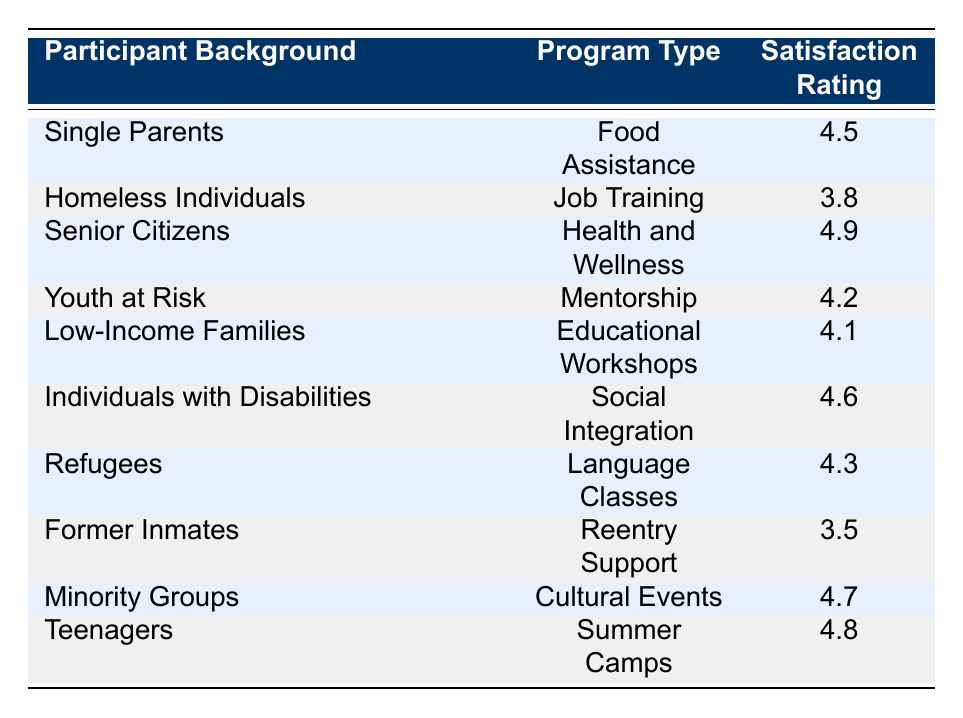What is the satisfaction rating for Senior Citizens in the Health and Wellness program? The table directly shows that the satisfaction rating for Senior Citizens participating in the Health and Wellness program is 4.9.
Answer: 4.9 Which program has the lowest satisfaction rating among participants? Upon reviewing the satisfaction ratings for all programs, the lowest rating is for Former Inmates in the Reentry Support program at 3.5.
Answer: 3.5 How many programs received a satisfaction rating of 4.5 or higher? The ratings that meet this criteria are: 4.5 for Single Parents (Food Assistance), 4.9 for Senior Citizens (Health and Wellness), 4.6 for Individuals with Disabilities (Social Integration), 4.7 for Minority Groups (Cultural Events), 4.8 for Teenagers (Summer Camps), and 4.2 for Youth at Risk (Mentorship), totaling 6 programs with ratings of 4.5 or higher.
Answer: 6 Is the satisfaction rating for Job Training greater than that for Food Assistance? Job Training, with a satisfaction rating of 3.8, is less than Food Assistance, which has a rating of 4.5. Thus, the statement is false.
Answer: No What is the average satisfaction rating of programs catering to Low-Income Families and Refugees? The rating for Low-Income Families in Educational Workshops is 4.1, and for Refugees in Language Classes, it is 4.3. The average is calculated as (4.1 + 4.3) / 2 = 4.2.
Answer: 4.2 Which participant background has the highest satisfaction rating, and what is that rating? The participant background with the highest satisfaction rating is Senior Citizens, who rated the Health and Wellness program at 4.9.
Answer: Senior Citizens, 4.9 How do the satisfaction ratings of programs for Homeless Individuals and Former Inmates compare? Homeless Individuals have a satisfaction rating of 3.8 for Job Training, while Former Inmates have a lower rating of 3.5 for Reentry Support. Thus, Homeless Individuals have a higher rating.
Answer: Homeless Individuals have a higher rating What is the satisfaction rating difference between Cultural Events and Summer Camps? Cultural Events received a rating of 4.7, while Summer Camps received 4.8. The difference is calculated as 4.8 - 4.7 = 0.1.
Answer: 0.1 